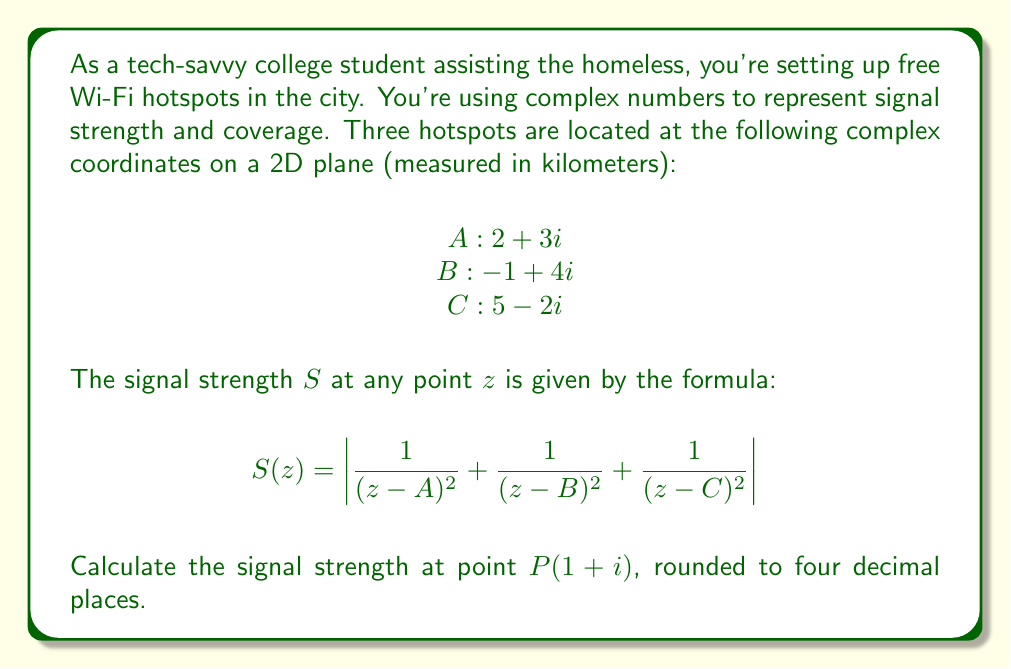What is the answer to this math problem? Let's approach this step-by-step:

1) First, we need to calculate $(z-A)$, $(z-B)$, and $(z-C)$:

   $z-A = (1+i) - (2+3i) = -1-2i$
   $z-B = (1+i) - (-1+4i) = 2-3i$
   $z-C = (1+i) - (5-2i) = -4+3i$

2) Now, we need to square these differences:

   $(z-A)^2 = (-1-2i)^2 = 1+4i+4i^2 = -3+4i$
   $(z-B)^2 = (2-3i)^2 = 4-12i+9i^2 = -5-12i$
   $(z-C)^2 = (-4+3i)^2 = 16-24i+9i^2 = 7-24i$

3) Next, we calculate the reciprocals:

   $\frac{1}{(z-A)^2} = \frac{1}{-3+4i} = \frac{-3-4i}{(-3)^2+(4)^2} = \frac{-3-4i}{25} = -0.12-0.16i$
   $\frac{1}{(z-B)^2} = \frac{1}{-5-12i} = \frac{-5+12i}{(-5)^2+(12)^2} = \frac{-5+12i}{169} \approx -0.0296+0.0710i$
   $\frac{1}{(z-C)^2} = \frac{1}{7-24i} = \frac{7+24i}{7^2+(24)^2} = \frac{7+24i}{625} = 0.0112+0.0384i$

4) Now we sum these reciprocals:

   $\sum = (-0.12-0.16i) + (-0.0296+0.0710i) + (0.0112+0.0384i) = -0.1384-0.0506i$

5) Finally, we take the absolute value (magnitude) of this complex number:

   $|S(z)| = |-0.1384-0.0506i| = \sqrt{(-0.1384)^2 + (-0.0506)^2} \approx 0.1472$
Answer: The signal strength at point $P(1+i)$ is approximately $0.1472$. 